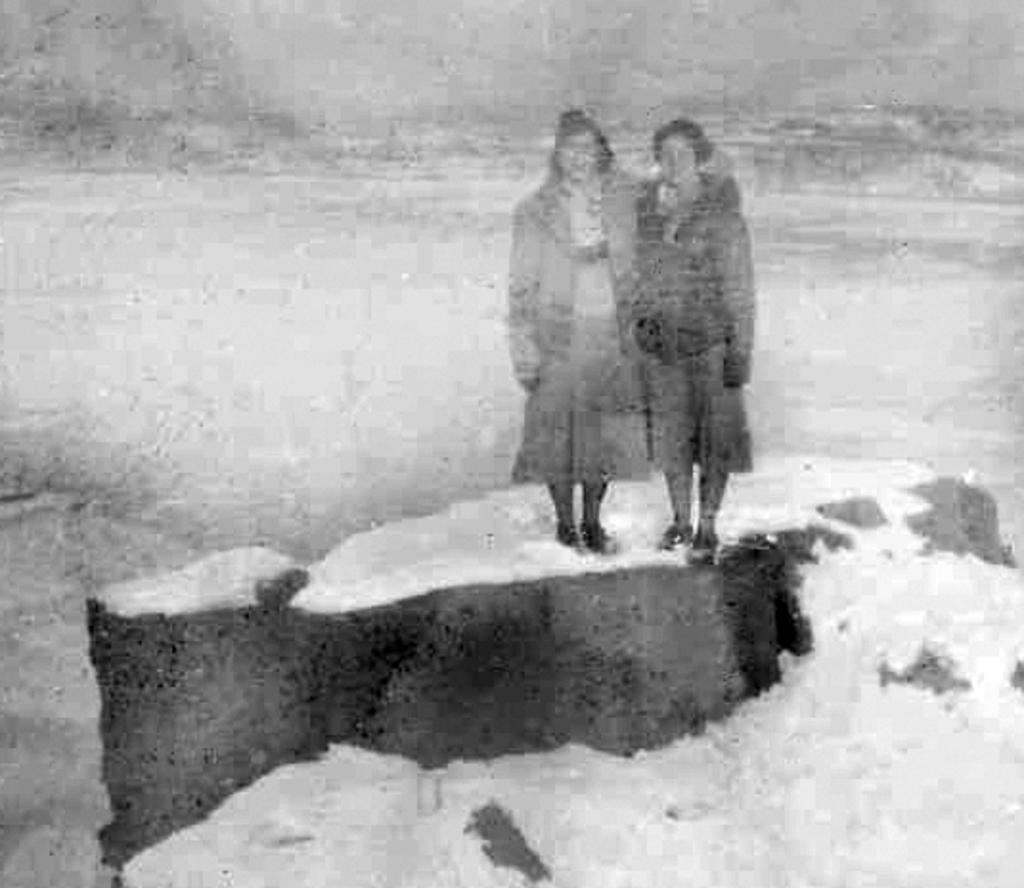How would you summarize this image in a sentence or two? I see this is a blurred image and I see 2 persons over here who are on the white surface and it is grey and white in the background. 